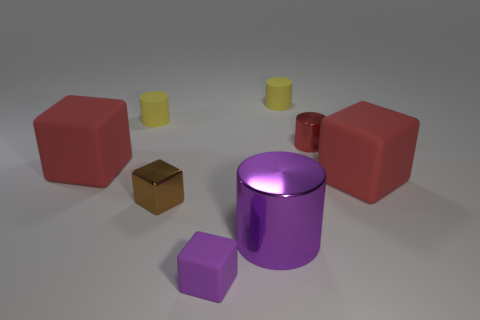Subtract all rubber cubes. How many cubes are left? 1 Subtract all purple cylinders. How many cylinders are left? 3 Subtract 1 blocks. How many blocks are left? 3 Add 1 small purple cylinders. How many objects exist? 9 Add 3 big cubes. How many big cubes are left? 5 Add 3 rubber cylinders. How many rubber cylinders exist? 5 Subtract 0 red balls. How many objects are left? 8 Subtract all cyan blocks. Subtract all blue spheres. How many blocks are left? 4 Subtract all brown cylinders. How many yellow cubes are left? 0 Subtract all matte things. Subtract all large things. How many objects are left? 0 